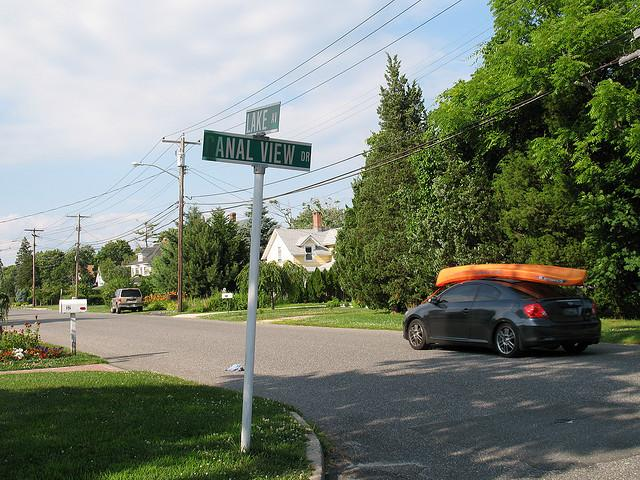What type of tool do you need to move while in the object on top of the black car? paddle 